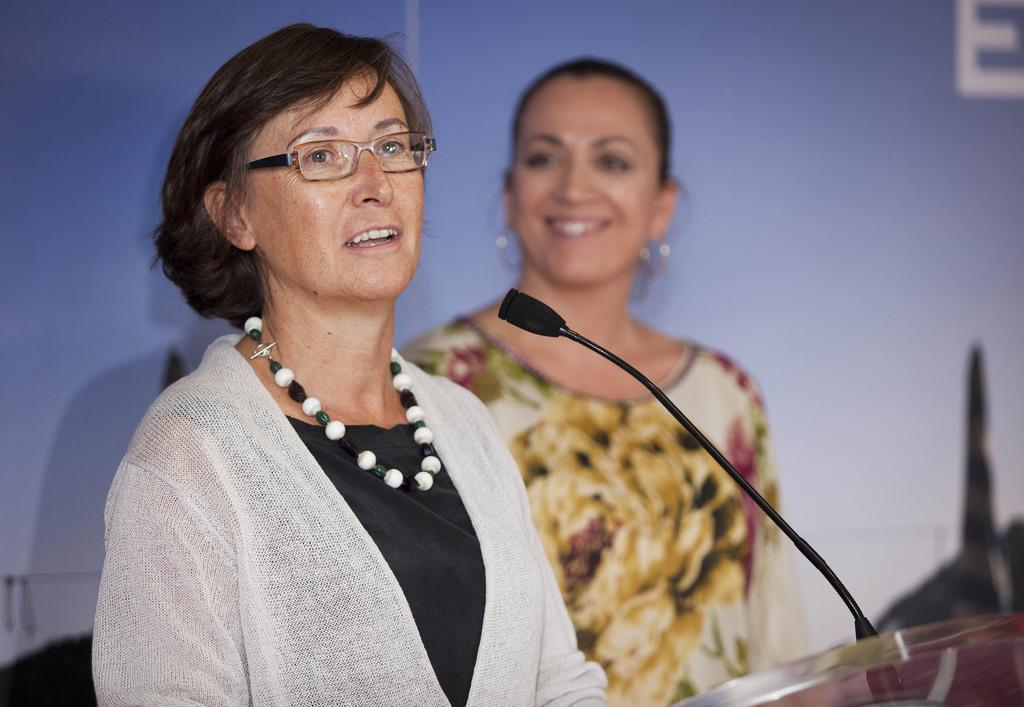How many people are in the image? There are two women in the image. What is one of the women doing in the image? One of the women is standing in front of a microphone. What is the woman in front of the microphone doing? The woman in front of the microphone is talking. How many boats are visible in the image? There are no boats present in the image. What type of parenting advice is the woman giving in the image? The image does not show the woman giving any parenting advice; she is talking in front of a microphone, but the topic is not specified. 